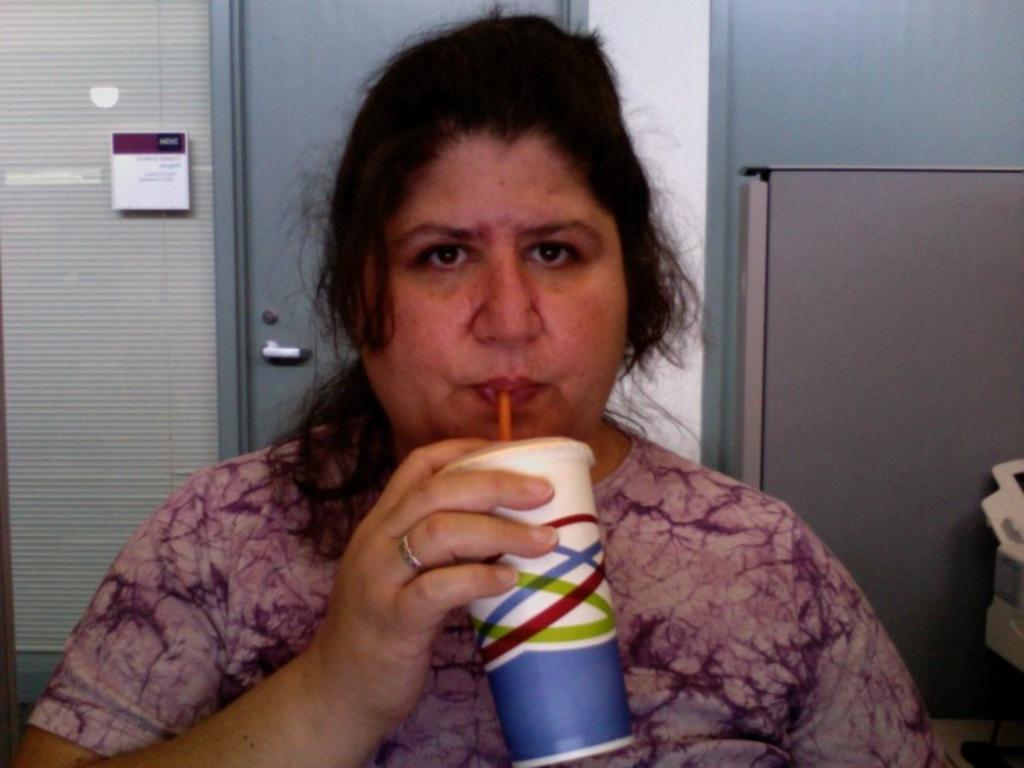How would you summarize this image in a sentence or two? In this image, we can see a woman, she is drinking some liquid, in the background we can see a door. 